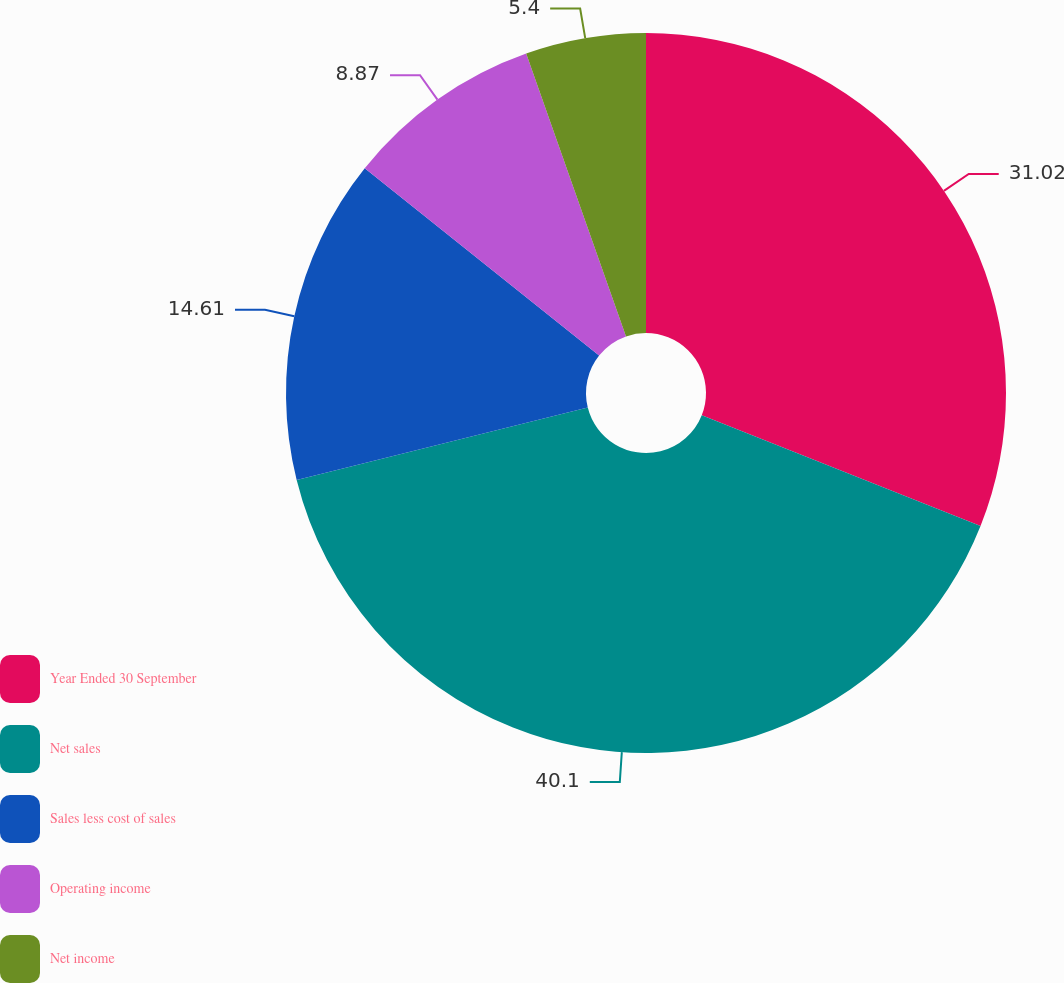<chart> <loc_0><loc_0><loc_500><loc_500><pie_chart><fcel>Year Ended 30 September<fcel>Net sales<fcel>Sales less cost of sales<fcel>Operating income<fcel>Net income<nl><fcel>31.02%<fcel>40.09%<fcel>14.61%<fcel>8.87%<fcel>5.4%<nl></chart> 